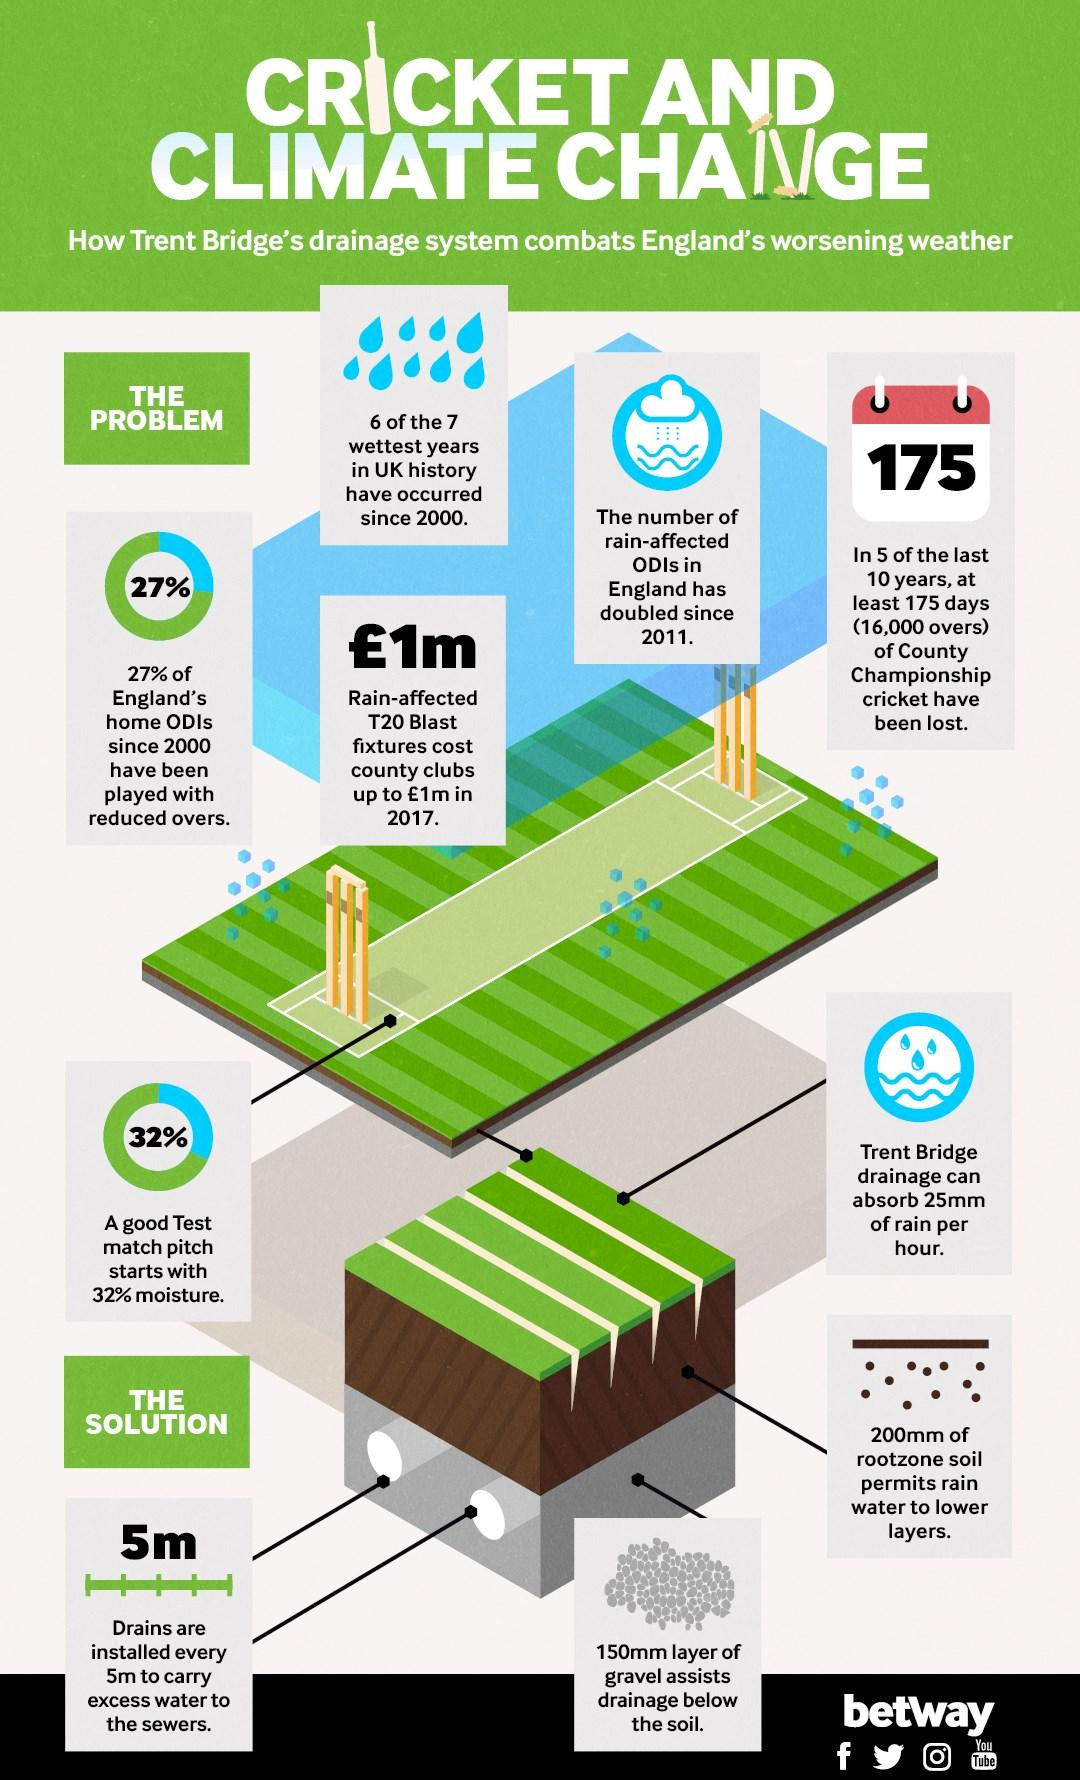Outline some significant characteristics in this image. The use of a 150mm layer of gravel assists in drainage below the soil. The area between the wickets, commonly referred to as the pitch, is the playing surface of a cricket field. A significant percentage of ODIs played since 2000 have been played with the correct overs, with 73% of them being played with the appropriate number of overs. 